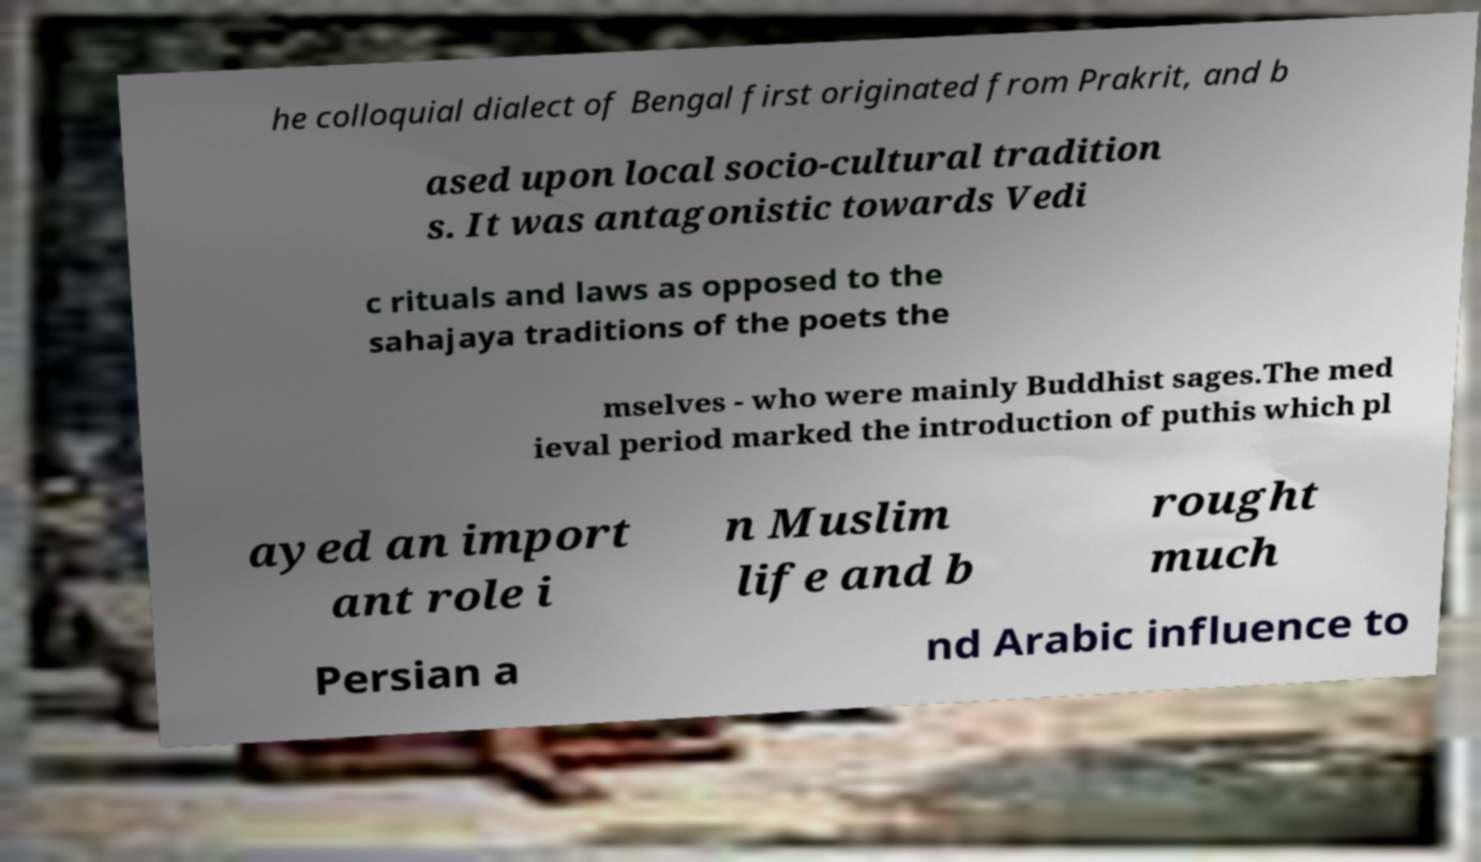Can you accurately transcribe the text from the provided image for me? he colloquial dialect of Bengal first originated from Prakrit, and b ased upon local socio-cultural tradition s. It was antagonistic towards Vedi c rituals and laws as opposed to the sahajaya traditions of the poets the mselves - who were mainly Buddhist sages.The med ieval period marked the introduction of puthis which pl ayed an import ant role i n Muslim life and b rought much Persian a nd Arabic influence to 